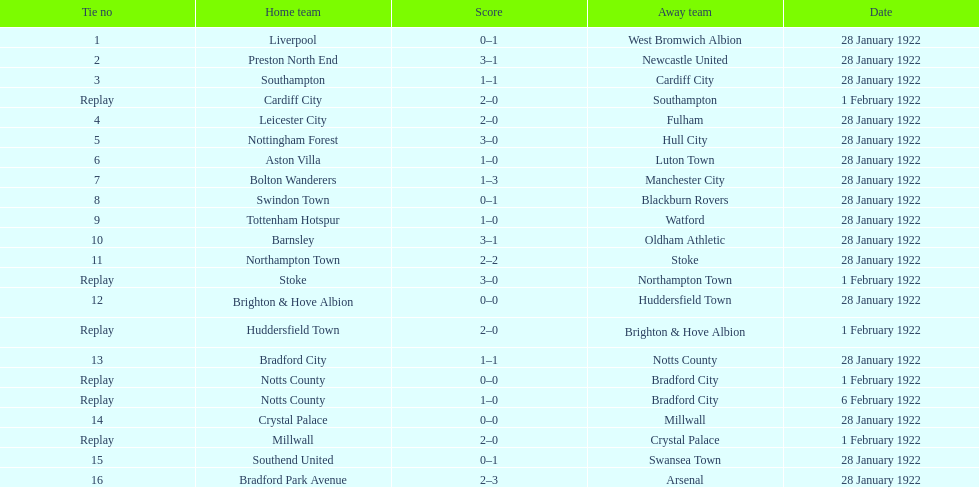How many games had four total points or more scored? 5. 